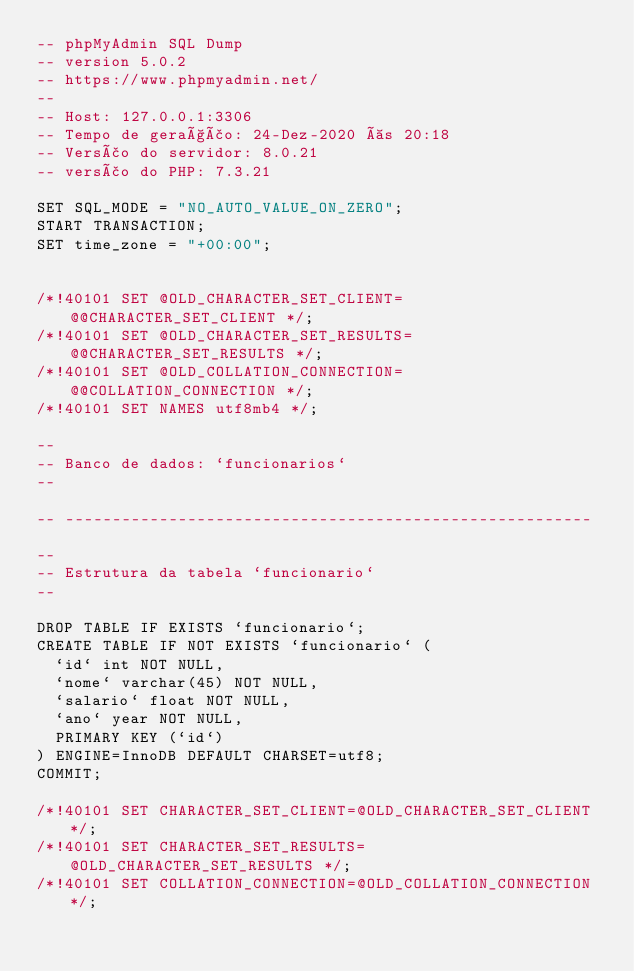<code> <loc_0><loc_0><loc_500><loc_500><_SQL_>-- phpMyAdmin SQL Dump
-- version 5.0.2
-- https://www.phpmyadmin.net/
--
-- Host: 127.0.0.1:3306
-- Tempo de geração: 24-Dez-2020 às 20:18
-- Versão do servidor: 8.0.21
-- versão do PHP: 7.3.21

SET SQL_MODE = "NO_AUTO_VALUE_ON_ZERO";
START TRANSACTION;
SET time_zone = "+00:00";


/*!40101 SET @OLD_CHARACTER_SET_CLIENT=@@CHARACTER_SET_CLIENT */;
/*!40101 SET @OLD_CHARACTER_SET_RESULTS=@@CHARACTER_SET_RESULTS */;
/*!40101 SET @OLD_COLLATION_CONNECTION=@@COLLATION_CONNECTION */;
/*!40101 SET NAMES utf8mb4 */;

--
-- Banco de dados: `funcionarios`
--

-- --------------------------------------------------------

--
-- Estrutura da tabela `funcionario`
--

DROP TABLE IF EXISTS `funcionario`;
CREATE TABLE IF NOT EXISTS `funcionario` (
  `id` int NOT NULL,
  `nome` varchar(45) NOT NULL,
  `salario` float NOT NULL,
  `ano` year NOT NULL,
  PRIMARY KEY (`id`)
) ENGINE=InnoDB DEFAULT CHARSET=utf8;
COMMIT;

/*!40101 SET CHARACTER_SET_CLIENT=@OLD_CHARACTER_SET_CLIENT */;
/*!40101 SET CHARACTER_SET_RESULTS=@OLD_CHARACTER_SET_RESULTS */;
/*!40101 SET COLLATION_CONNECTION=@OLD_COLLATION_CONNECTION */;
</code> 